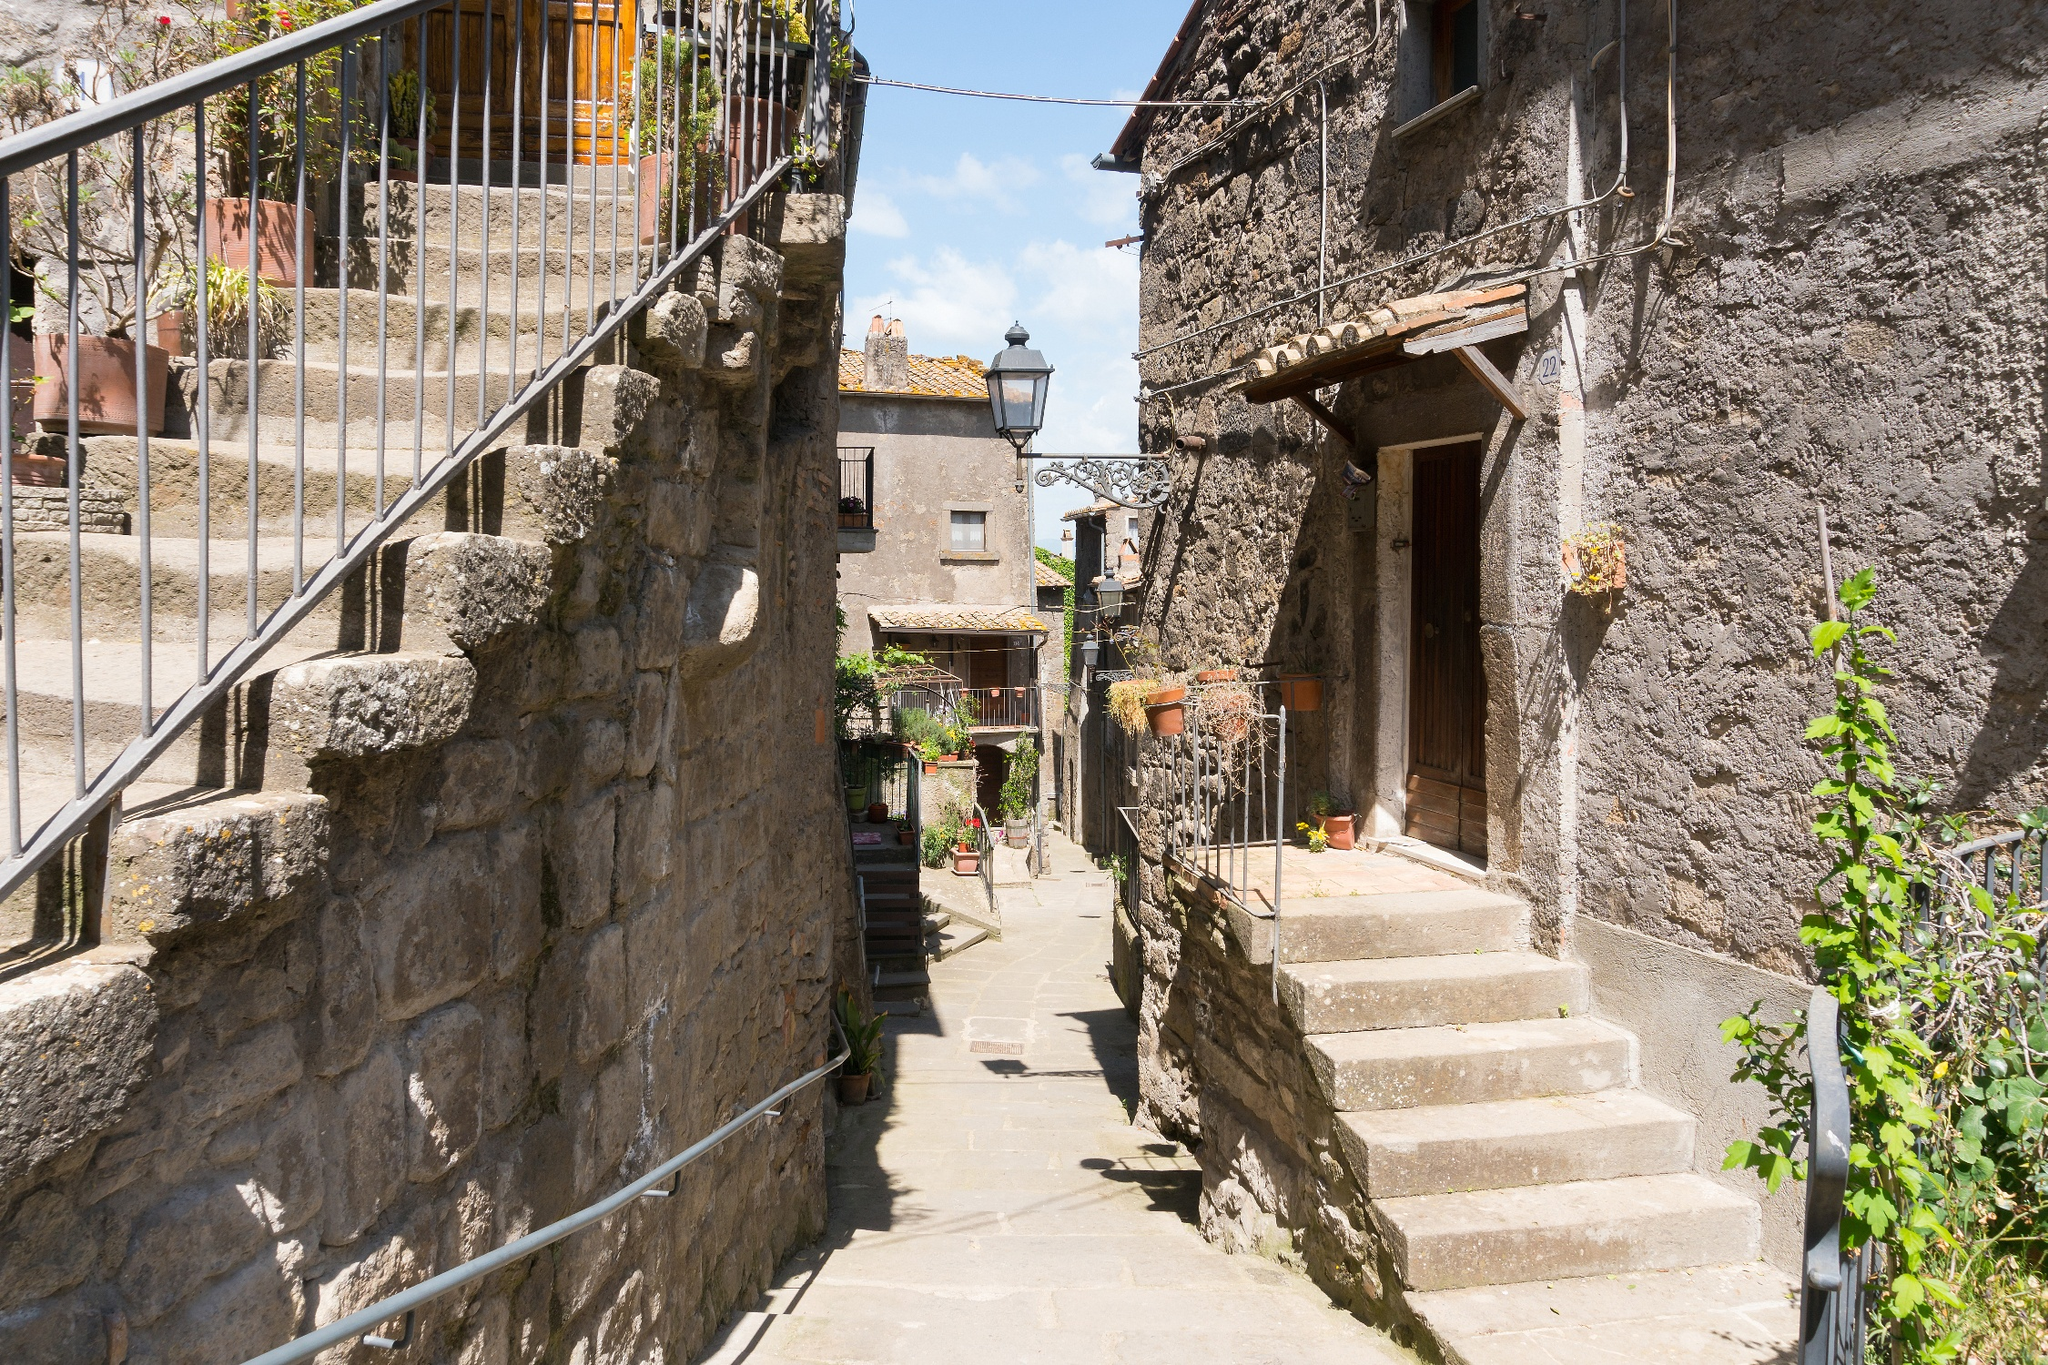Tell me a fairy tale that could take place in this village. Once upon a time, in a charming European village, there lived a kind-hearted girl named Clara. Clara had a rare gift – she could speak to the plants and animals around her. Every morning, she would wander the cobblestone streets, whispering secrets to the ivy on the stone walls and sharing stories with the birds perched on the red tiled roofs. One day, as Clara was tending to the plants in the courtyard near the fountain, she discovered a hidden door in the stone wall. Curiosity piqued, she opened the door to find a magical garden, glowing with colors she had never seen. In the garden, she met an old woman who revealed herself to be the village's ancient guardian. The guardian explained that the village was under a spell that could only be broken by someone pure of heart. Clara's kindness and ability to communicate with nature made her the chosen one. Through a series of adventures involving talking animals and enchanted trails, Clara gathered the ingredients needed to lift the spell. In the end, the village was bathed in eternal sunlight, and Clara's bravery brought everlasting joy and prosperity to her beloved home. To this day, the villagers celebrate Clara's heroic deeds, and the hidden garden remains a place of magic and wonder. 